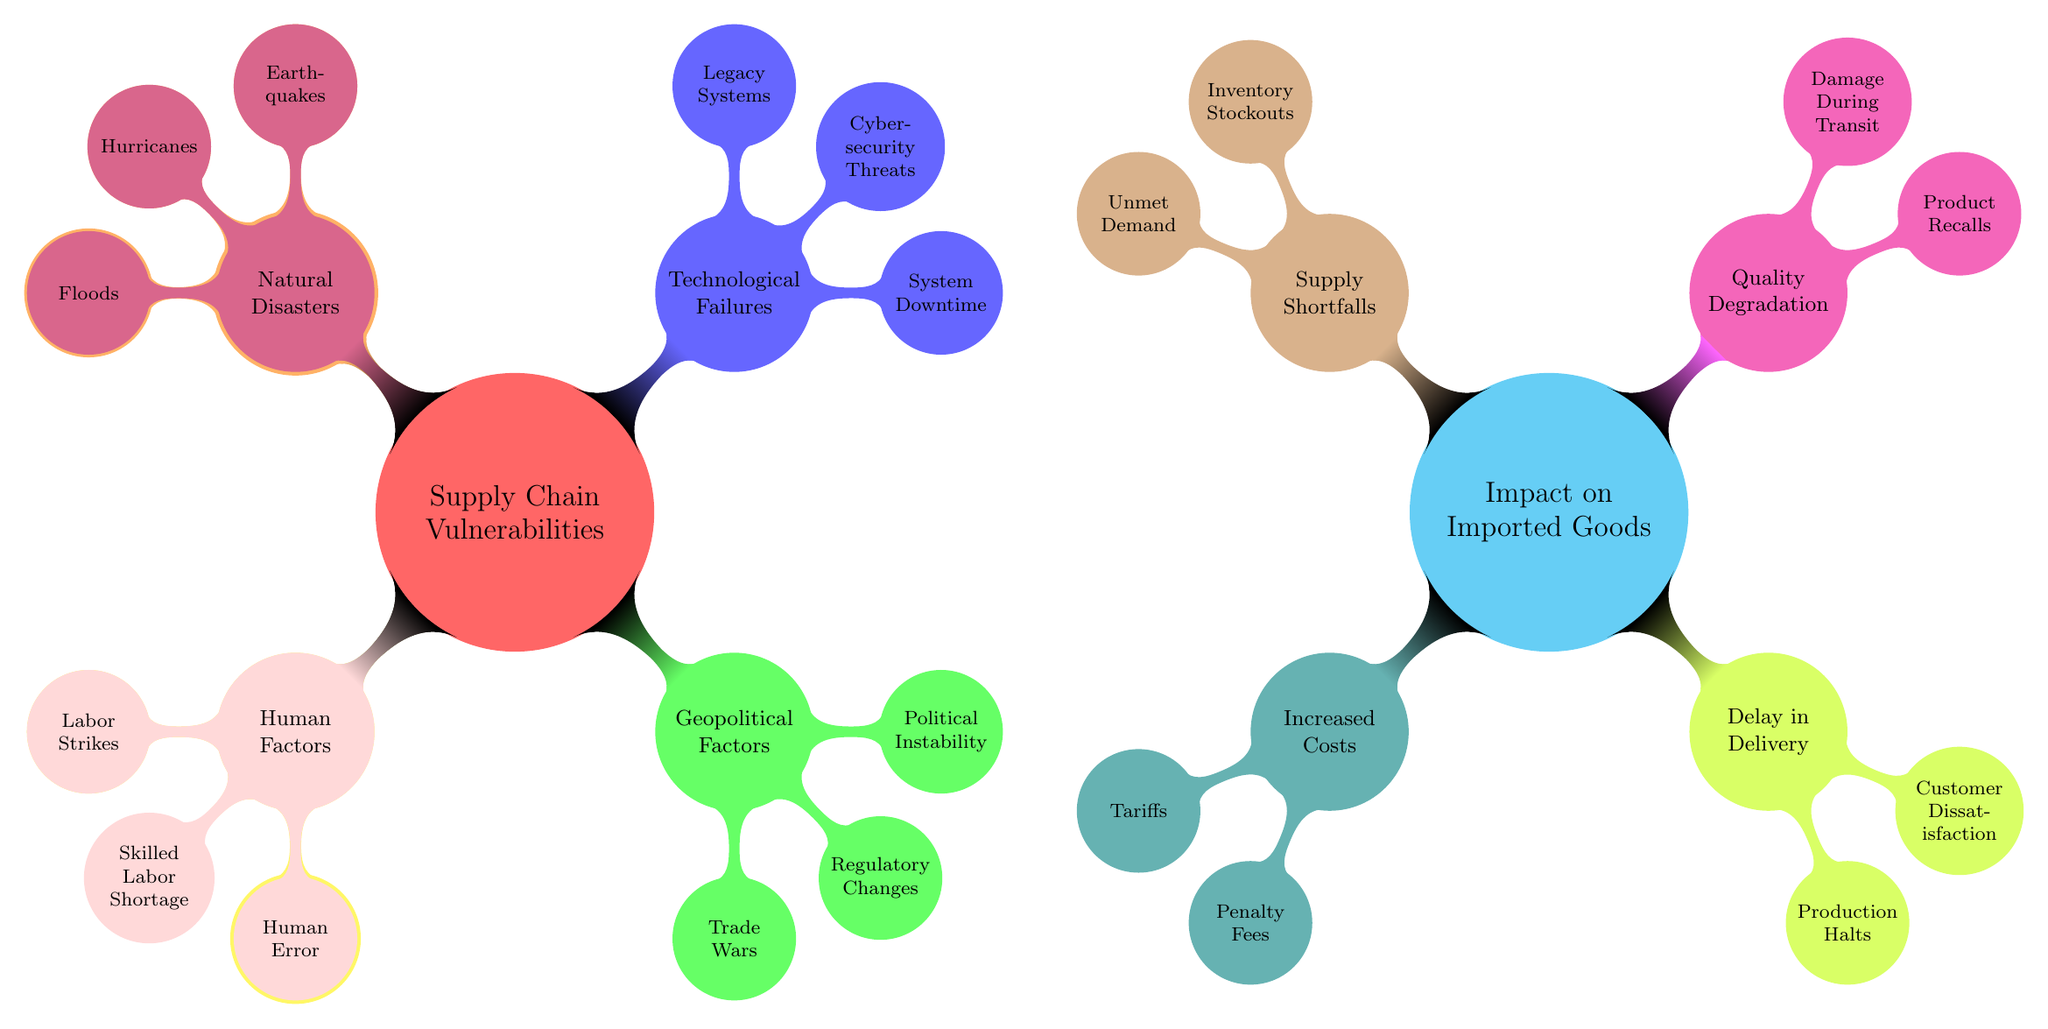What are the two main categories of vulnerabilities in the diagram? The diagram contains two main categories: 'Supply Chain Vulnerabilities' and 'Impact on Imported Goods.' Each category includes specific nodes outlining various aspects related to them.
Answer: Supply Chain Vulnerabilities, Impact on Imported Goods How many subcategories are there under 'Human Factors'? Under 'Human Factors', there are three subcategories: 'Labor Strikes,' 'Skilled Labor Shortage,' and 'Human Error.' The count is derived from counting the child nodes directly connected to the 'Human Factors' node.
Answer: 3 What is an example of a 'Geopolitical Factor'? The diagram lists three subcategories under 'Geopolitical Factors': 'Trade Wars,' 'Regulatory Changes,' and 'Political Instability.' Any of these can serve as an example. Selecting one, 'Trade Wars' fits this category.
Answer: Trade Wars Which category includes 'System Downtime'? 'System Downtime' is a subcategory under 'Technological Failures'. The relationship is established by identifying the hierarchy in the mind map, where 'Technological Failures' is a parent node of 'System Downtime.'
Answer: Technological Failures What type of impact does 'Quality Degradation' signify? 'Quality Degradation' refers to a negative effect on the quality of imported goods, which is one of the major impacts outlined under the 'Impact on Imported Goods' section of the diagram.
Answer: Negative effect on quality Name two outcomes associated with 'Delay in Delivery'. 'Delay in Delivery' includes two outcomes: 'Production Halts' and 'Customer Dissatisfaction.' Both outcomes are direct subcategories listed under the 'Delay in Delivery' category.
Answer: Production Halts, Customer Dissatisfaction How are 'Natural Disasters' categorized? 'Natural Disasters' is classified as a category of 'Supply Chain Vulnerabilities'. This can be understood by checking the main nodes under 'Supply Chain Vulnerabilities' and locating where 'Natural Disasters' falls.
Answer: Supply Chain Vulnerabilities Which node has the least number of sub-nodes? The node 'Port Congestion' under 'Transportation Disruptions' has no sub-nodes, indicating it is the least detailed compared to others in the same category.
Answer: Port Congestion What relationship exists between 'Inventory Stockouts' and 'Supply Shortfalls'? 'Inventory Stockouts' is a specific outcome that results from 'Supply Shortfalls'. This shows a cause-and-effect connection in the context of supply chain dynamics as represented in the mind map.
Answer: Cause-and-effect connection 